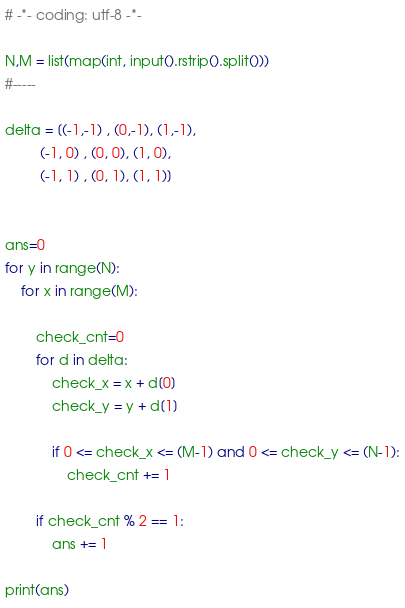Convert code to text. <code><loc_0><loc_0><loc_500><loc_500><_Python_># -*- coding: utf-8 -*-

N,M = list(map(int, input().rstrip().split()))
#-----

delta = [(-1,-1) , (0,-1), (1,-1),
         (-1, 0) , (0, 0), (1, 0),
         (-1, 1) , (0, 1), (1, 1)]


ans=0
for y in range(N):
    for x in range(M):
        
        check_cnt=0
        for d in delta:
            check_x = x + d[0]
            check_y = y + d[1]
            
            if 0 <= check_x <= (M-1) and 0 <= check_y <= (N-1):
                check_cnt += 1
        
        if check_cnt % 2 == 1:
            ans += 1

print(ans)
</code> 